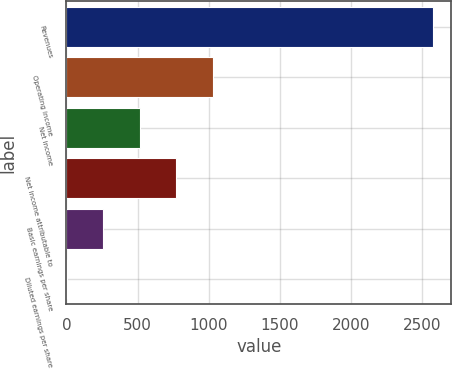<chart> <loc_0><loc_0><loc_500><loc_500><bar_chart><fcel>Revenues<fcel>Operating income<fcel>Net income<fcel>Net income attributable to<fcel>Basic earnings per share<fcel>Diluted earnings per share<nl><fcel>2575<fcel>1030.56<fcel>515.76<fcel>773.16<fcel>258.36<fcel>0.96<nl></chart> 